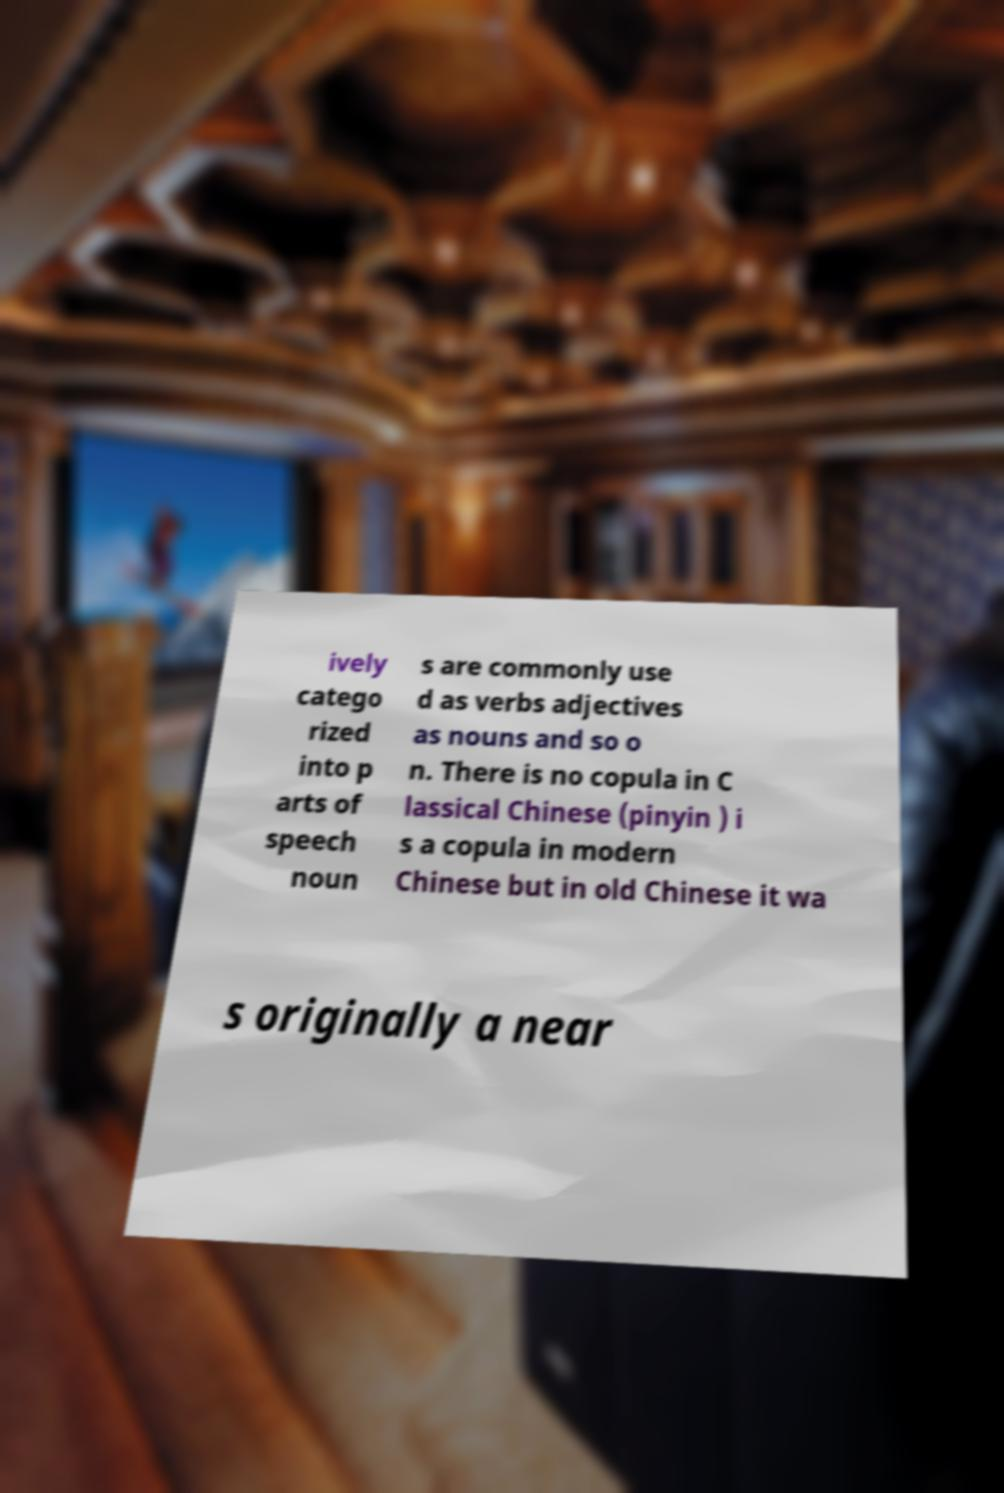For documentation purposes, I need the text within this image transcribed. Could you provide that? ively catego rized into p arts of speech noun s are commonly use d as verbs adjectives as nouns and so o n. There is no copula in C lassical Chinese (pinyin ) i s a copula in modern Chinese but in old Chinese it wa s originally a near 